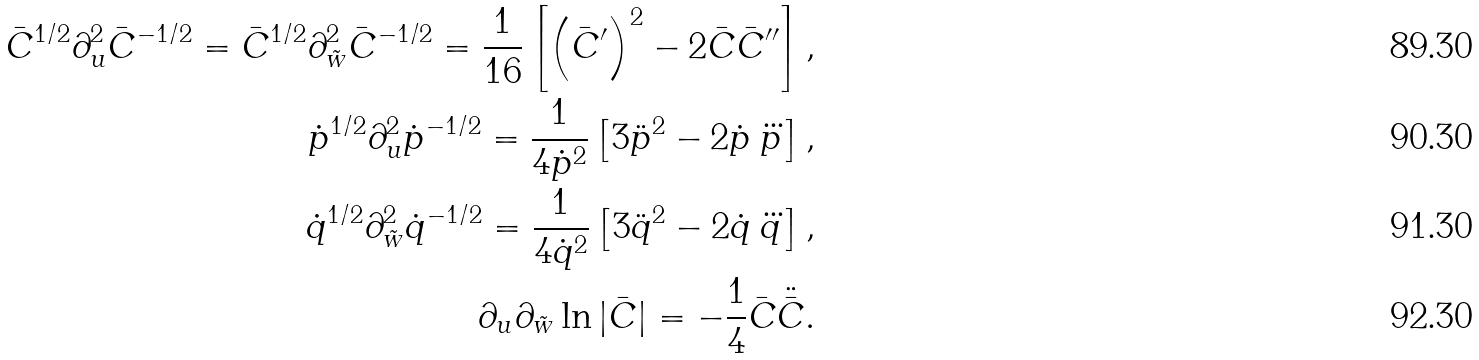Convert formula to latex. <formula><loc_0><loc_0><loc_500><loc_500>\bar { C } ^ { 1 / 2 } \partial _ { u } ^ { 2 } \bar { C } ^ { - 1 / 2 } = \bar { C } ^ { 1 / 2 } \partial _ { \tilde { w } } ^ { 2 } \bar { C } ^ { - 1 / 2 } = \frac { 1 } { 1 6 } \left [ { \left ( \bar { C } ^ { \prime } \right ) } ^ { 2 } - 2 \bar { C } \bar { C } ^ { \prime \prime } \right ] , \\ \dot { p } ^ { 1 / 2 } \partial _ { u } ^ { 2 } \dot { p } ^ { - 1 / 2 } = \frac { 1 } { 4 \dot { p } ^ { 2 } } \left [ 3 \ddot { p } ^ { 2 } - 2 \dot { p } \, \dddot { p } \right ] , \\ \dot { q } ^ { 1 / 2 } \partial _ { \tilde { w } } ^ { 2 } \dot { q } ^ { - 1 / 2 } = \frac { 1 } { 4 \dot { q } ^ { 2 } } \left [ 3 \ddot { q } ^ { 2 } - 2 \dot { q } \, \dddot { q } \right ] , \\ \partial _ { u } \partial _ { \tilde { w } } \ln | \bar { C } | = - \frac { 1 } { 4 } \bar { C } \ddot { \bar { C } } .</formula> 